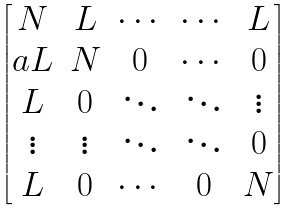<formula> <loc_0><loc_0><loc_500><loc_500>\begin{bmatrix} N & L & \cdots & \cdots & L \\ a L & N & 0 & \cdots & 0 \\ L & 0 & \ddots & \ddots & \vdots \\ \vdots & \vdots & \ddots & \ddots & 0 \\ L & 0 & \cdots & 0 & N \end{bmatrix}</formula> 